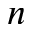Convert formula to latex. <formula><loc_0><loc_0><loc_500><loc_500>n</formula> 